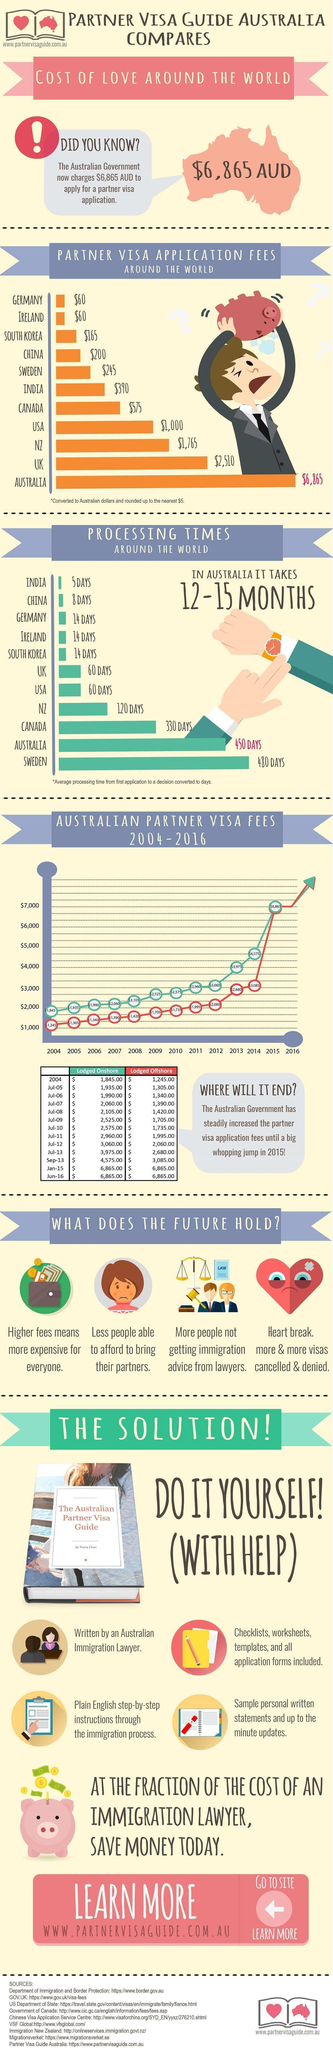Which country has the second longest processing time?
Answer the question with a short phrase. Australia Which country has the fourth lowest fees for partner visa application? China What is the increase in visa fees for application lodged onshore from 2004 to june 2016 ? $5,020.00 What is the increase in visa fees for application lodged offshore from 2004 to june 2016 ? $5,620.00 Which country has the least processing time? India Which country has the fourth Highest fees for partner visa application? USA Which country has the third Highest fees for partner visa application? NZ Which country has the third lowest fees for partner visa application? South Korea 